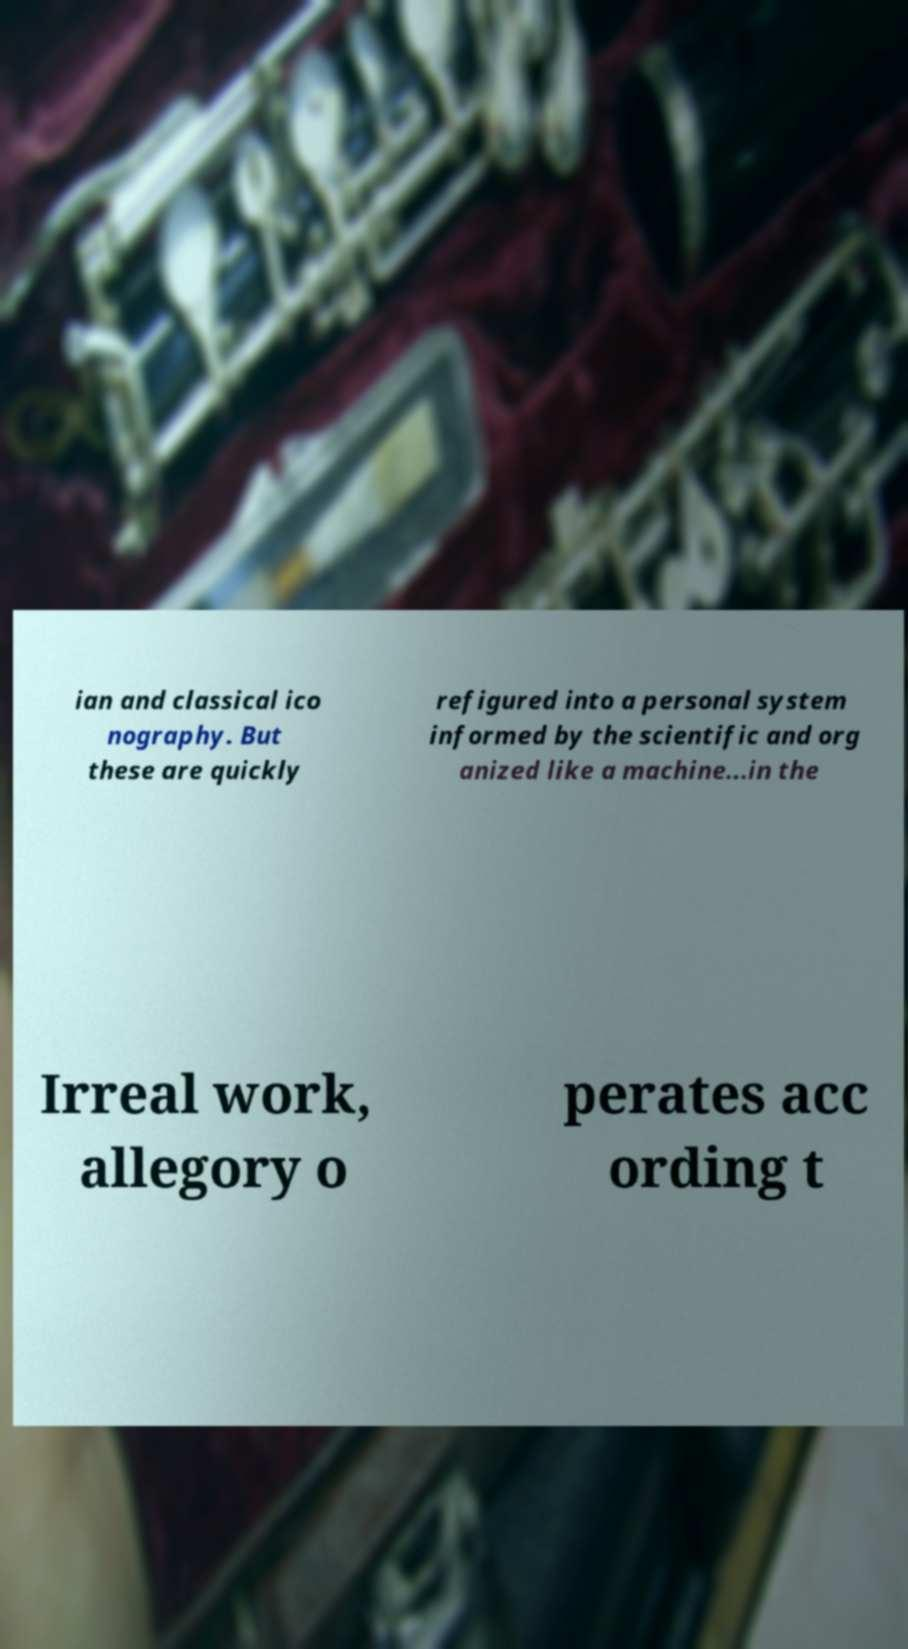Can you read and provide the text displayed in the image?This photo seems to have some interesting text. Can you extract and type it out for me? ian and classical ico nography. But these are quickly refigured into a personal system informed by the scientific and org anized like a machine...in the Irreal work, allegory o perates acc ording t 